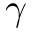<formula> <loc_0><loc_0><loc_500><loc_500>\gamma</formula> 